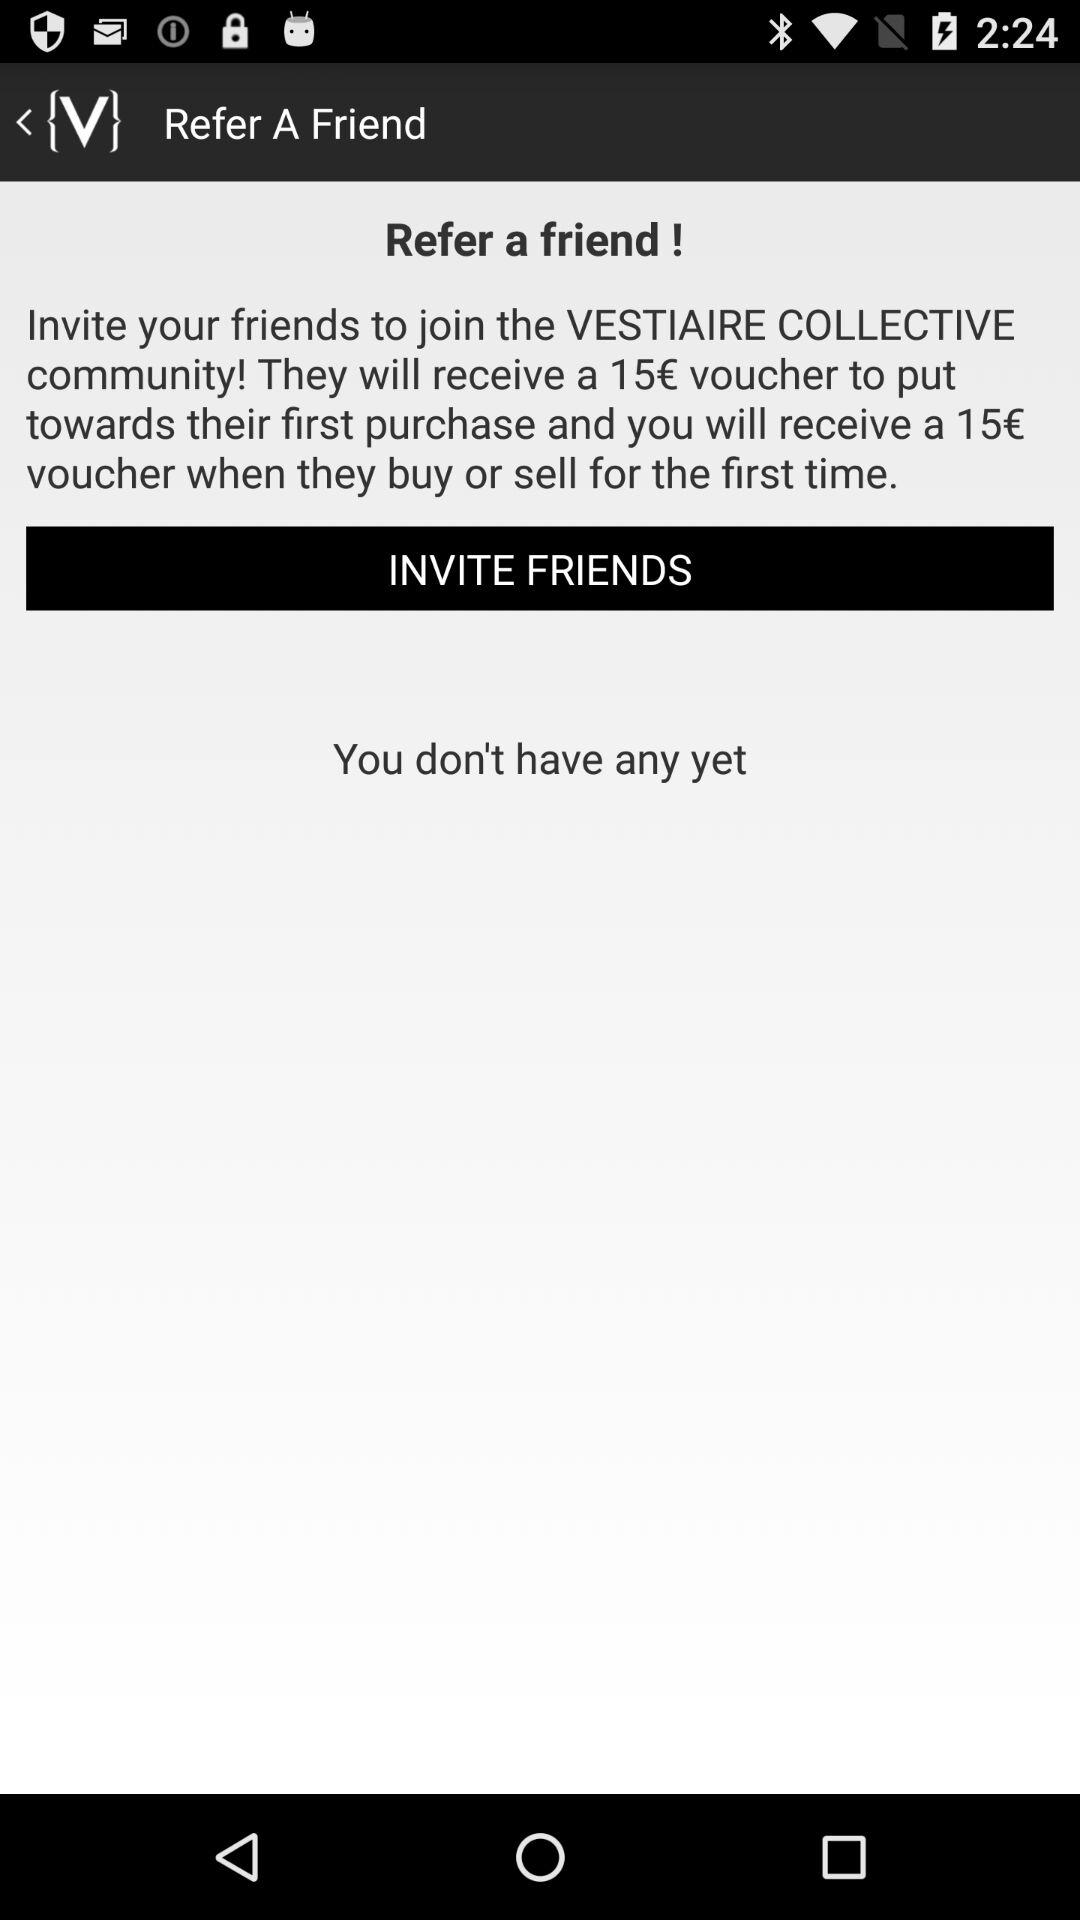How many vouchers do I get when my friend buys or sells for the first time?
Answer the question using a single word or phrase. 15€ 